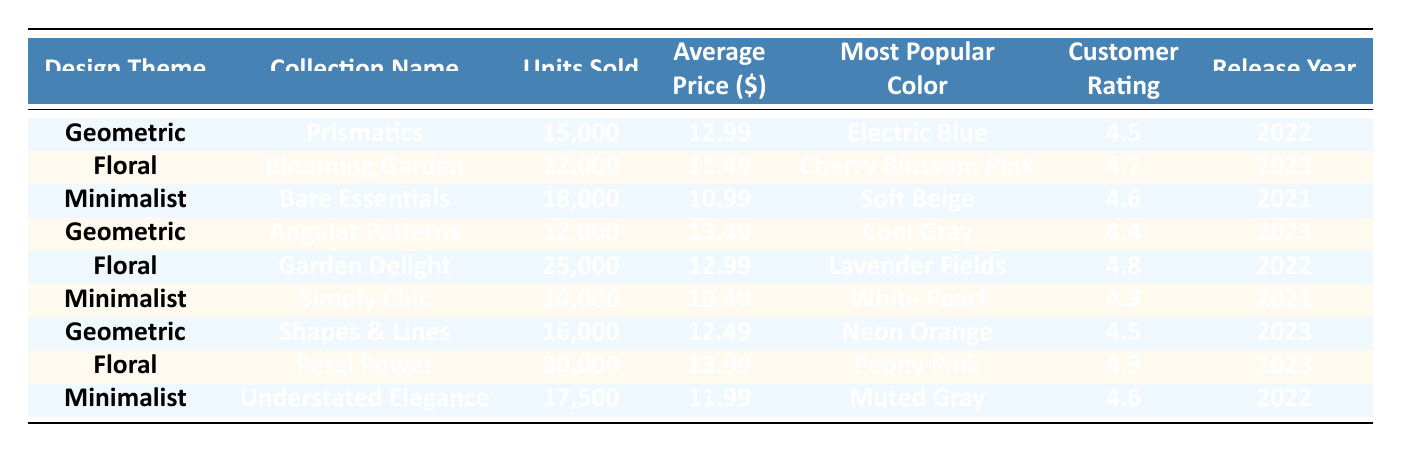What is the most popular color in the "Blooming Garden" collection? The "Blooming Garden" collection is under the Floral design theme. According to the table, the most popular color in this collection is "Cherry Blossom Pink."
Answer: Cherry Blossom Pink How many units did the "Petal Power" collection sell? In the table, for the "Petal Power" collection under the Floral design theme, the number of units sold listed is 30,000.
Answer: 30,000 Which design theme had the highest customer rating? When reviewing the customer ratings across all design themes, "Petal Power" has the highest rating at 4.9. Thus, the Floral design theme includes the highest rated collection.
Answer: Floral What is the average price of the Geometric collections? To find the average price of the Geometric collections, we take the prices of "Prismatics" (12.99), "Angular Patterns" (13.49), and "Shapes & Lines" (12.49). Summing these: 12.99 + 13.49 + 12.49 = 38.97. Then divide by the number of collections (3) to find the average: 38.97 / 3 = 12.99.
Answer: 12.99 Did any Minimalist collection sell more than 17,500 units? The Minimalist collections listed are "Bare Essentials" (18,000) and "Understated Elegance" (17,500). Since "Bare Essentials" sold more than 17,500 units while "Understated Elegance" sold exactly 17,500, the answer is yes.
Answer: Yes What is the total number of units sold in the Floral collections? The Floral collections are "Blooming Garden" (22,000), "Garden Delight" (25,000), and "Petal Power" (30,000). To find the total, sum these values: 22,000 + 25,000 + 30,000 = 77,000.
Answer: 77,000 Which collection has the lowest average price, and what is that price? Reviewing the average prices in the collection data, "Simply Chic" has the lowest average price at 10.49.
Answer: 10.49 Which design theme had the most collections sold in 2023? The collections sold in 2023 are "Blooming Garden," "Angular Patterns," "Shapes & Lines," and "Petal Power." Counting, we find 4 collections were sold in 2023, which are largely from the Floral and Geometric themes. However, "Petal Power" had the most units sold.
Answer: Floral and Geometric (4 collections) What is the release year of the collection that sold the fewest units? In the data, "Angular Patterns" sold the fewest units at 12,000 and was released in 2023.
Answer: 2023 